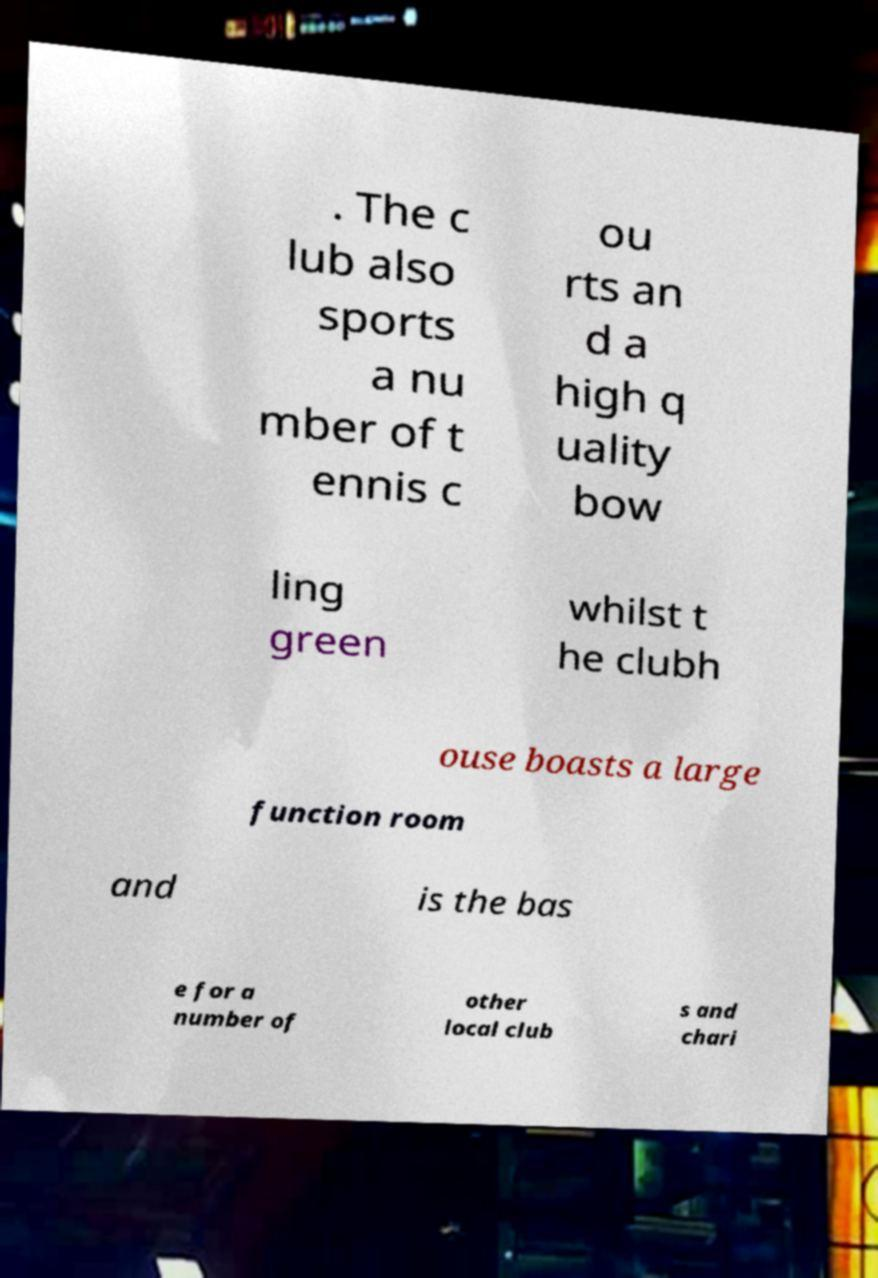Please identify and transcribe the text found in this image. . The c lub also sports a nu mber of t ennis c ou rts an d a high q uality bow ling green whilst t he clubh ouse boasts a large function room and is the bas e for a number of other local club s and chari 